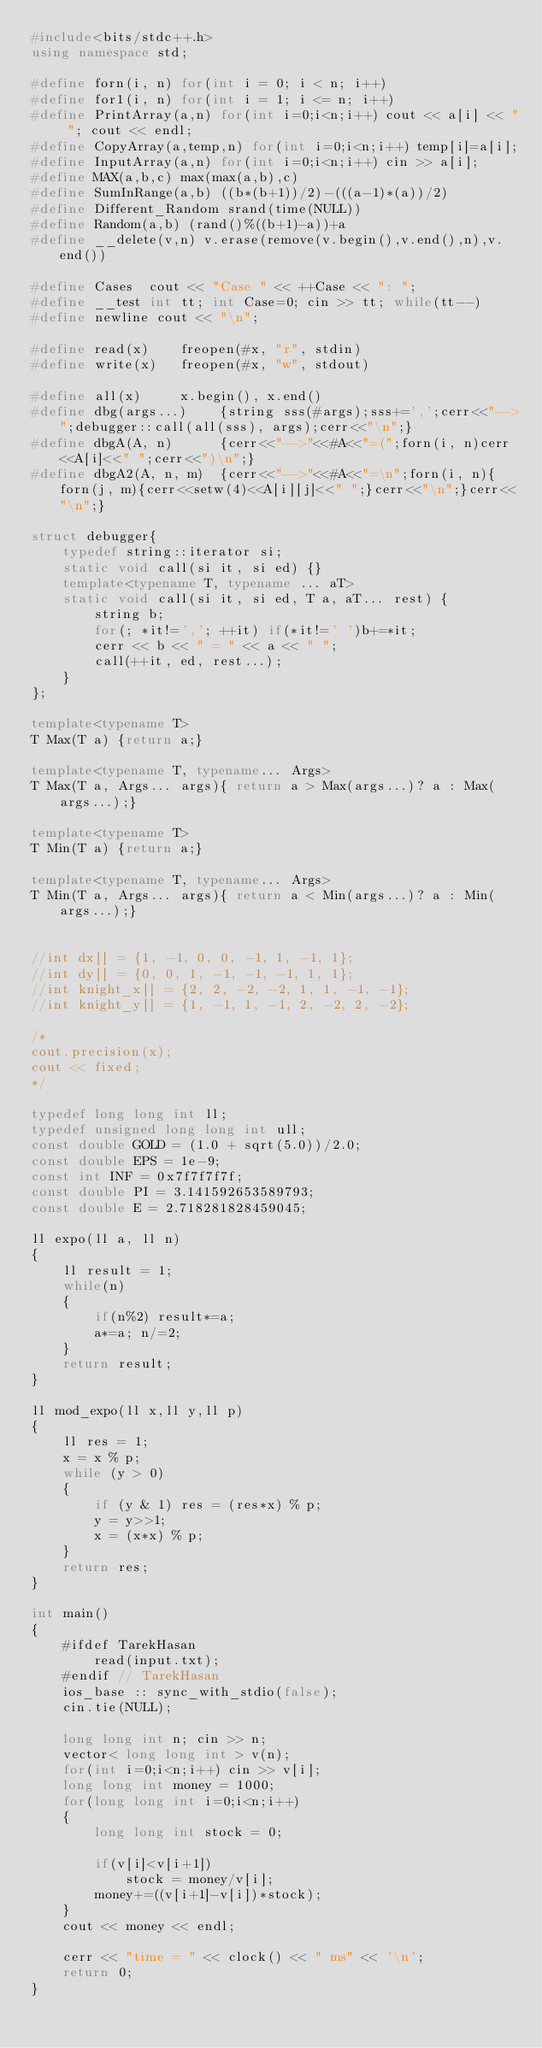Convert code to text. <code><loc_0><loc_0><loc_500><loc_500><_C++_>#include<bits/stdc++.h>
using namespace std;

#define forn(i, n) for(int i = 0; i < n; i++)
#define for1(i, n) for(int i = 1; i <= n; i++)
#define PrintArray(a,n) for(int i=0;i<n;i++) cout << a[i] << " "; cout << endl;
#define CopyArray(a,temp,n) for(int i=0;i<n;i++) temp[i]=a[i];
#define InputArray(a,n) for(int i=0;i<n;i++) cin >> a[i];
#define MAX(a,b,c) max(max(a,b),c)
#define SumInRange(a,b) ((b*(b+1))/2)-(((a-1)*(a))/2)
#define Different_Random srand(time(NULL))
#define Random(a,b) (rand()%((b+1)-a))+a
#define __delete(v,n) v.erase(remove(v.begin(),v.end(),n),v.end())

#define Cases  cout << "Case " << ++Case << ": ";
#define __test int tt; int Case=0; cin >> tt; while(tt--)
#define newline cout << "\n";

#define read(x)    freopen(#x, "r", stdin)
#define write(x)   freopen(#x, "w", stdout)

#define all(x)     x.begin(), x.end()
#define dbg(args...)    {string sss(#args);sss+=',';cerr<<"-->";debugger::call(all(sss), args);cerr<<"\n";}
#define dbgA(A, n)      {cerr<<"-->"<<#A<<"=(";forn(i, n)cerr<<A[i]<<" ";cerr<<")\n";}
#define dbgA2(A, n, m)  {cerr<<"-->"<<#A<<"=\n";forn(i, n){forn(j, m){cerr<<setw(4)<<A[i][j]<<" ";}cerr<<"\n";}cerr<<"\n";}

struct debugger{
    typedef string::iterator si;
    static void call(si it, si ed) {}
    template<typename T, typename ... aT>
    static void call(si it, si ed, T a, aT... rest) {
        string b;
        for(; *it!=','; ++it) if(*it!=' ')b+=*it;
        cerr << b << " = " << a << " ";
        call(++it, ed, rest...);
    }
};

template<typename T>
T Max(T a) {return a;}

template<typename T, typename... Args>
T Max(T a, Args... args){ return a > Max(args...)? a : Max(args...);}

template<typename T>
T Min(T a) {return a;}

template<typename T, typename... Args>
T Min(T a, Args... args){ return a < Min(args...)? a : Min(args...);}


//int dx[] = {1, -1, 0, 0, -1, 1, -1, 1};
//int dy[] = {0, 0, 1, -1, -1, -1, 1, 1};
//int knight_x[] = {2, 2, -2, -2, 1, 1, -1, -1};
//int knight_y[] = {1, -1, 1, -1, 2, -2, 2, -2};

/*
cout.precision(x);
cout << fixed;
*/

typedef long long int ll;
typedef unsigned long long int ull;
const double GOLD = (1.0 + sqrt(5.0))/2.0;
const double EPS = 1e-9;
const int INF = 0x7f7f7f7f;
const double PI = 3.141592653589793;
const double E = 2.718281828459045;

ll expo(ll a, ll n)
{
    ll result = 1;
    while(n)
    {
        if(n%2) result*=a;
        a*=a; n/=2;
    }
    return result;
}

ll mod_expo(ll x,ll y,ll p)
{
    ll res = 1;
    x = x % p;
    while (y > 0)
    {
        if (y & 1) res = (res*x) % p;
        y = y>>1;
        x = (x*x) % p;
    }
    return res;
}

int main()
{
    #ifdef TarekHasan
        read(input.txt);
    #endif // TarekHasan
    ios_base :: sync_with_stdio(false);
    cin.tie(NULL);

    long long int n; cin >> n;
    vector< long long int > v(n);
    for(int i=0;i<n;i++) cin >> v[i];
    long long int money = 1000;
    for(long long int i=0;i<n;i++)
    {
        long long int stock = 0;

        if(v[i]<v[i+1])
            stock = money/v[i];
        money+=((v[i+1]-v[i])*stock);
    }
    cout << money << endl;

    cerr << "time = " << clock() << " ms" << '\n';
    return 0;
}

</code> 